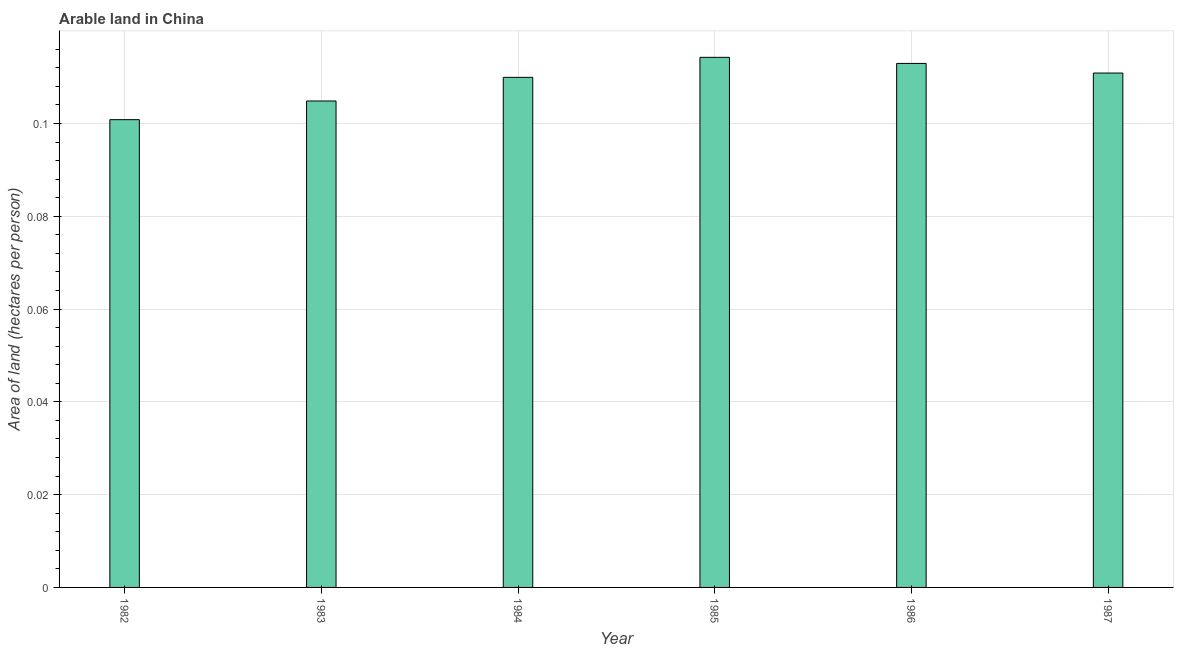Does the graph contain any zero values?
Your answer should be very brief. No. What is the title of the graph?
Ensure brevity in your answer.  Arable land in China. What is the label or title of the Y-axis?
Make the answer very short. Area of land (hectares per person). What is the area of arable land in 1985?
Give a very brief answer. 0.11. Across all years, what is the maximum area of arable land?
Your answer should be compact. 0.11. Across all years, what is the minimum area of arable land?
Your response must be concise. 0.1. In which year was the area of arable land maximum?
Make the answer very short. 1985. What is the sum of the area of arable land?
Give a very brief answer. 0.65. What is the difference between the area of arable land in 1983 and 1985?
Your answer should be compact. -0.01. What is the average area of arable land per year?
Offer a terse response. 0.11. What is the median area of arable land?
Keep it short and to the point. 0.11. Is the difference between the area of arable land in 1983 and 1987 greater than the difference between any two years?
Give a very brief answer. No. Is the sum of the area of arable land in 1982 and 1986 greater than the maximum area of arable land across all years?
Give a very brief answer. Yes. What is the difference between the highest and the lowest area of arable land?
Provide a succinct answer. 0.01. In how many years, is the area of arable land greater than the average area of arable land taken over all years?
Provide a succinct answer. 4. Are all the bars in the graph horizontal?
Provide a succinct answer. No. How many years are there in the graph?
Provide a succinct answer. 6. What is the difference between two consecutive major ticks on the Y-axis?
Provide a short and direct response. 0.02. Are the values on the major ticks of Y-axis written in scientific E-notation?
Make the answer very short. No. What is the Area of land (hectares per person) of 1982?
Ensure brevity in your answer.  0.1. What is the Area of land (hectares per person) in 1983?
Offer a terse response. 0.1. What is the Area of land (hectares per person) of 1984?
Offer a very short reply. 0.11. What is the Area of land (hectares per person) of 1985?
Your answer should be very brief. 0.11. What is the Area of land (hectares per person) of 1986?
Keep it short and to the point. 0.11. What is the Area of land (hectares per person) in 1987?
Give a very brief answer. 0.11. What is the difference between the Area of land (hectares per person) in 1982 and 1983?
Your response must be concise. -0. What is the difference between the Area of land (hectares per person) in 1982 and 1984?
Offer a terse response. -0.01. What is the difference between the Area of land (hectares per person) in 1982 and 1985?
Your response must be concise. -0.01. What is the difference between the Area of land (hectares per person) in 1982 and 1986?
Give a very brief answer. -0.01. What is the difference between the Area of land (hectares per person) in 1982 and 1987?
Offer a very short reply. -0.01. What is the difference between the Area of land (hectares per person) in 1983 and 1984?
Keep it short and to the point. -0.01. What is the difference between the Area of land (hectares per person) in 1983 and 1985?
Offer a terse response. -0.01. What is the difference between the Area of land (hectares per person) in 1983 and 1986?
Provide a short and direct response. -0.01. What is the difference between the Area of land (hectares per person) in 1983 and 1987?
Give a very brief answer. -0.01. What is the difference between the Area of land (hectares per person) in 1984 and 1985?
Provide a short and direct response. -0. What is the difference between the Area of land (hectares per person) in 1984 and 1986?
Your answer should be compact. -0. What is the difference between the Area of land (hectares per person) in 1984 and 1987?
Provide a short and direct response. -0. What is the difference between the Area of land (hectares per person) in 1985 and 1986?
Offer a very short reply. 0. What is the difference between the Area of land (hectares per person) in 1985 and 1987?
Give a very brief answer. 0. What is the difference between the Area of land (hectares per person) in 1986 and 1987?
Keep it short and to the point. 0. What is the ratio of the Area of land (hectares per person) in 1982 to that in 1983?
Offer a very short reply. 0.96. What is the ratio of the Area of land (hectares per person) in 1982 to that in 1984?
Your answer should be compact. 0.92. What is the ratio of the Area of land (hectares per person) in 1982 to that in 1985?
Your response must be concise. 0.88. What is the ratio of the Area of land (hectares per person) in 1982 to that in 1986?
Give a very brief answer. 0.89. What is the ratio of the Area of land (hectares per person) in 1982 to that in 1987?
Provide a succinct answer. 0.91. What is the ratio of the Area of land (hectares per person) in 1983 to that in 1984?
Keep it short and to the point. 0.95. What is the ratio of the Area of land (hectares per person) in 1983 to that in 1985?
Give a very brief answer. 0.92. What is the ratio of the Area of land (hectares per person) in 1983 to that in 1986?
Your answer should be very brief. 0.93. What is the ratio of the Area of land (hectares per person) in 1983 to that in 1987?
Your answer should be very brief. 0.95. What is the ratio of the Area of land (hectares per person) in 1984 to that in 1985?
Your response must be concise. 0.96. What is the ratio of the Area of land (hectares per person) in 1984 to that in 1986?
Provide a short and direct response. 0.97. What is the ratio of the Area of land (hectares per person) in 1984 to that in 1987?
Provide a succinct answer. 0.99. What is the ratio of the Area of land (hectares per person) in 1985 to that in 1986?
Ensure brevity in your answer.  1.01. What is the ratio of the Area of land (hectares per person) in 1985 to that in 1987?
Offer a very short reply. 1.03. What is the ratio of the Area of land (hectares per person) in 1986 to that in 1987?
Offer a terse response. 1.02. 